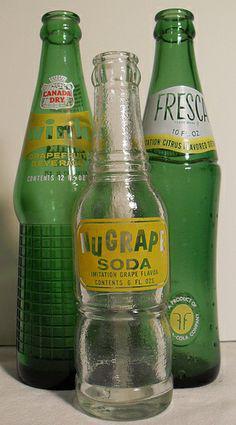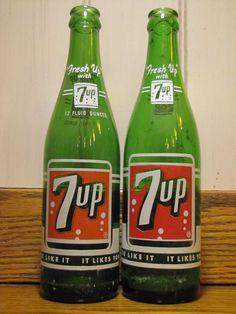The first image is the image on the left, the second image is the image on the right. Assess this claim about the two images: "There are exactly two green bottles in the right image, and multiple green bottles with a clear bottle in the left image.". Correct or not? Answer yes or no. Yes. The first image is the image on the left, the second image is the image on the right. Assess this claim about the two images: "Six or fewer bottles are visible.". Correct or not? Answer yes or no. Yes. 